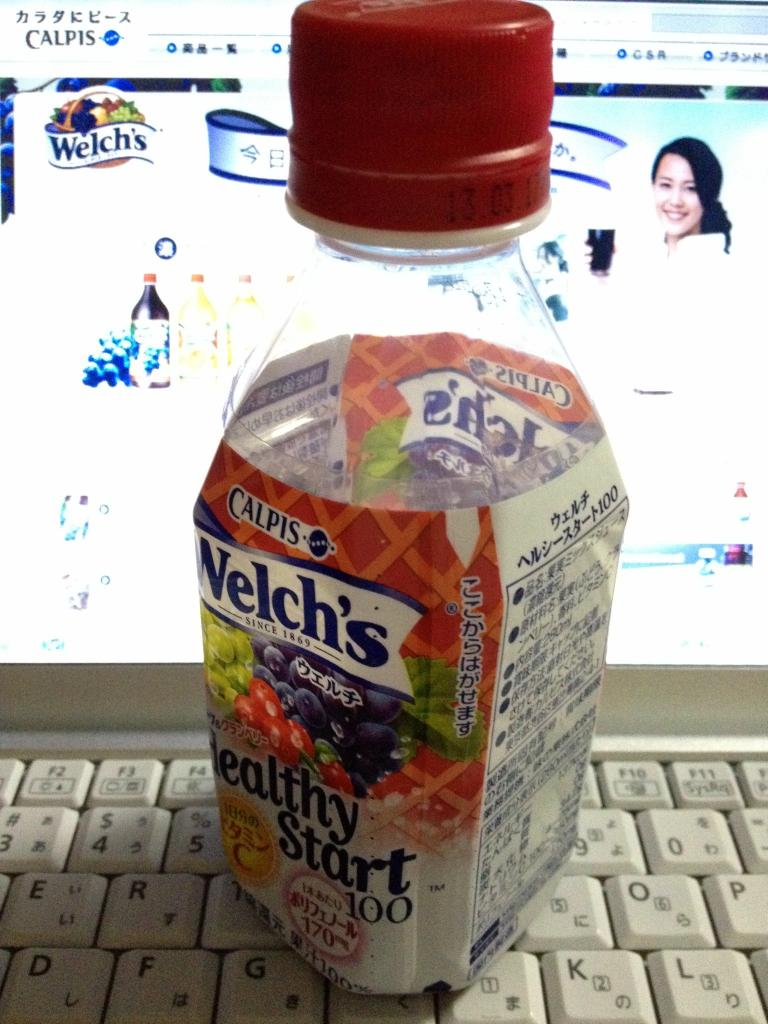What does the setting of this image suggest about the person who might be consuming this beverage? The setting features a computer monitor displaying an online drinks store and a keyboard, suggesting that the person consuming this beverage may be engaged in online shopping or working from a desk. It implies a likely multi-tasking, office or home-work environment, where convenience and health-oriented drinks like Welch’s 'Healthy Start 100' are appreciated. 